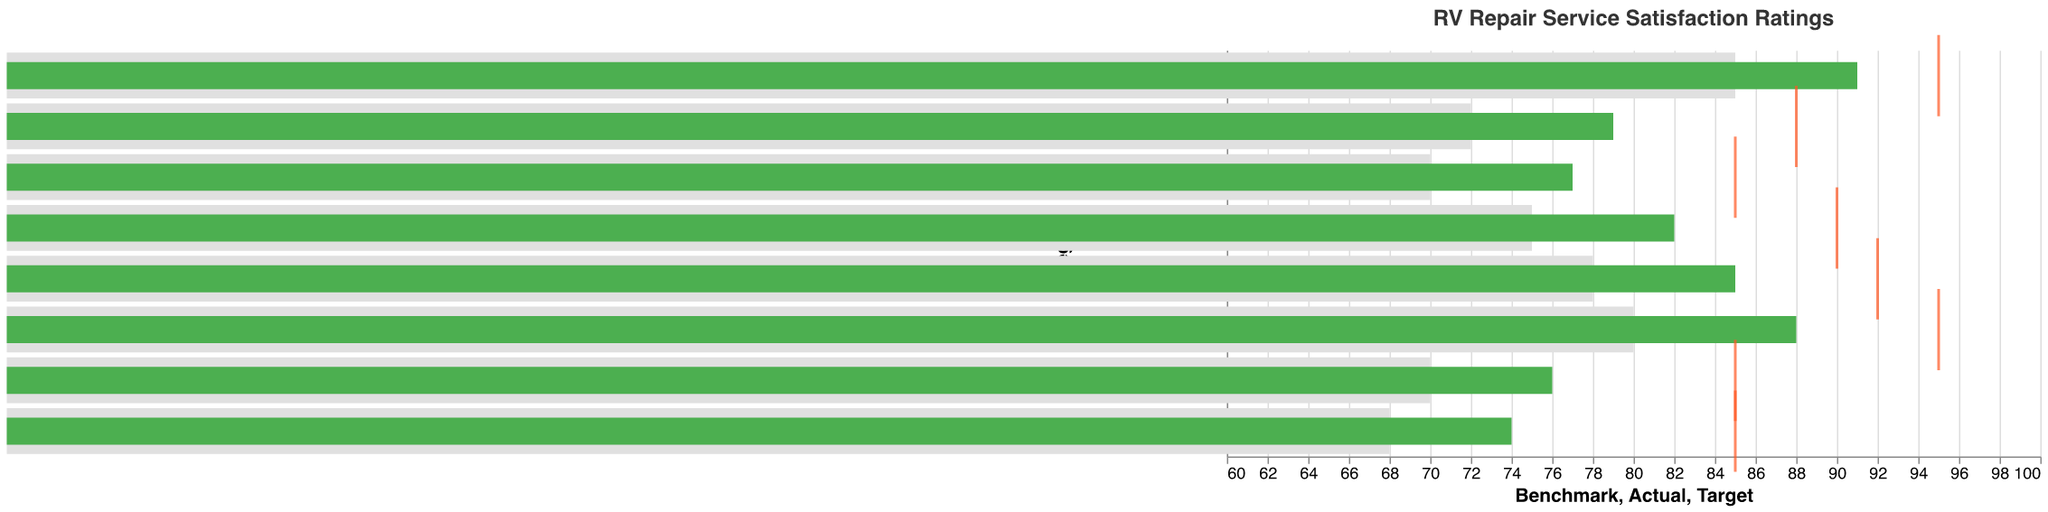How many different categories are displayed in the figure? The dataset includes a list of unique categories that represent different aspects of RV repair services: Overall Satisfaction, Technical Expertise, Timeliness, Communication, Value for Money, Parts Availability, Cleanliness, and Follow-up Service. Each category is one data point in the chart.
Answer: 8 Which service category has the highest satisfaction rating? To find the highest satisfaction rating, compare the "Actual" values for each category. Cleanliness has the highest value, which is 91.
Answer: Cleanliness What's the benchmark satisfaction rating for Communication? Look under the “Benchmark” field for the Communication category. The benchmark rating is given as 72.
Answer: 72 How does the actual rating for Timeliness compare to its benchmark? For Timeliness, compare the "Actual" rating (76) with the "Benchmark" rating (70). The actual rating is greater than the benchmark.
Answer: 76 is greater than 70 Which category is closest to meeting its target rating? Calculate the difference between the "Actual" and "Target" values for each category and identify the smallest difference. Cleanliness is closest with a difference of 4 (95 - 91).
Answer: Cleanliness What is the average benchmark rating across all categories? Sum the benchmark ratings for all categories (75 + 80 + 70 + 72 + 68 + 78 + 85 + 70) and divide by the number of categories, which is 8. The calculation is (598 / 8).
Answer: 74.75 Which category has the largest gap between its actual rating and its target rating? Find the difference between the "Actual" and "Target" for each category and identify the largest difference. Value for Money has the largest gap with 11 (85 - 74).
Answer: Value for Money Is the actual rating of Technical Expertise above its target rating? Compare the "Actual" rating of Technical Expertise (88) with its "Target" rating (95). Since 88 is less than 95, it is not above the target.
Answer: No How do the actual and benchmark ratings of Parts Availability compare? Compare the "Actual" rating (85) and "Benchmark" rating (78) for Parts Availability. The actual rating is greater than the benchmark rating.
Answer: 85 is greater than 78 Which category surpasses its benchmark by the largest margin? Determine the margin by subtracting Benchmark from Actual for each category and identifying the largest margin. Technical Expertise surpasses its benchmark by 8 (88 - 80).
Answer: Technical Expertise 